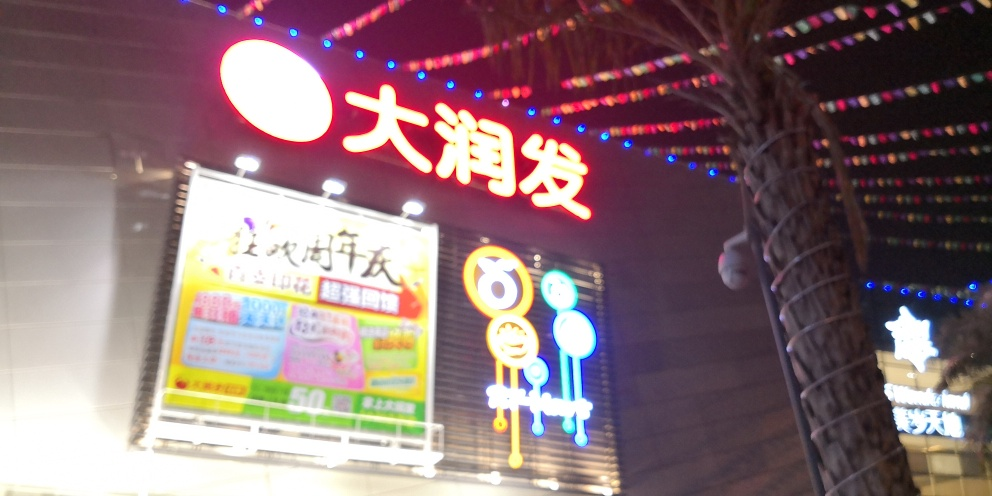Is there anything in the image that indicates the location or cultural setting? Yes, the use of Chinese characters on the signs indicates that the setting is in a region where Chinese is predominantly spoken, such as China, Taiwan, or a Chinatown district in another country. 